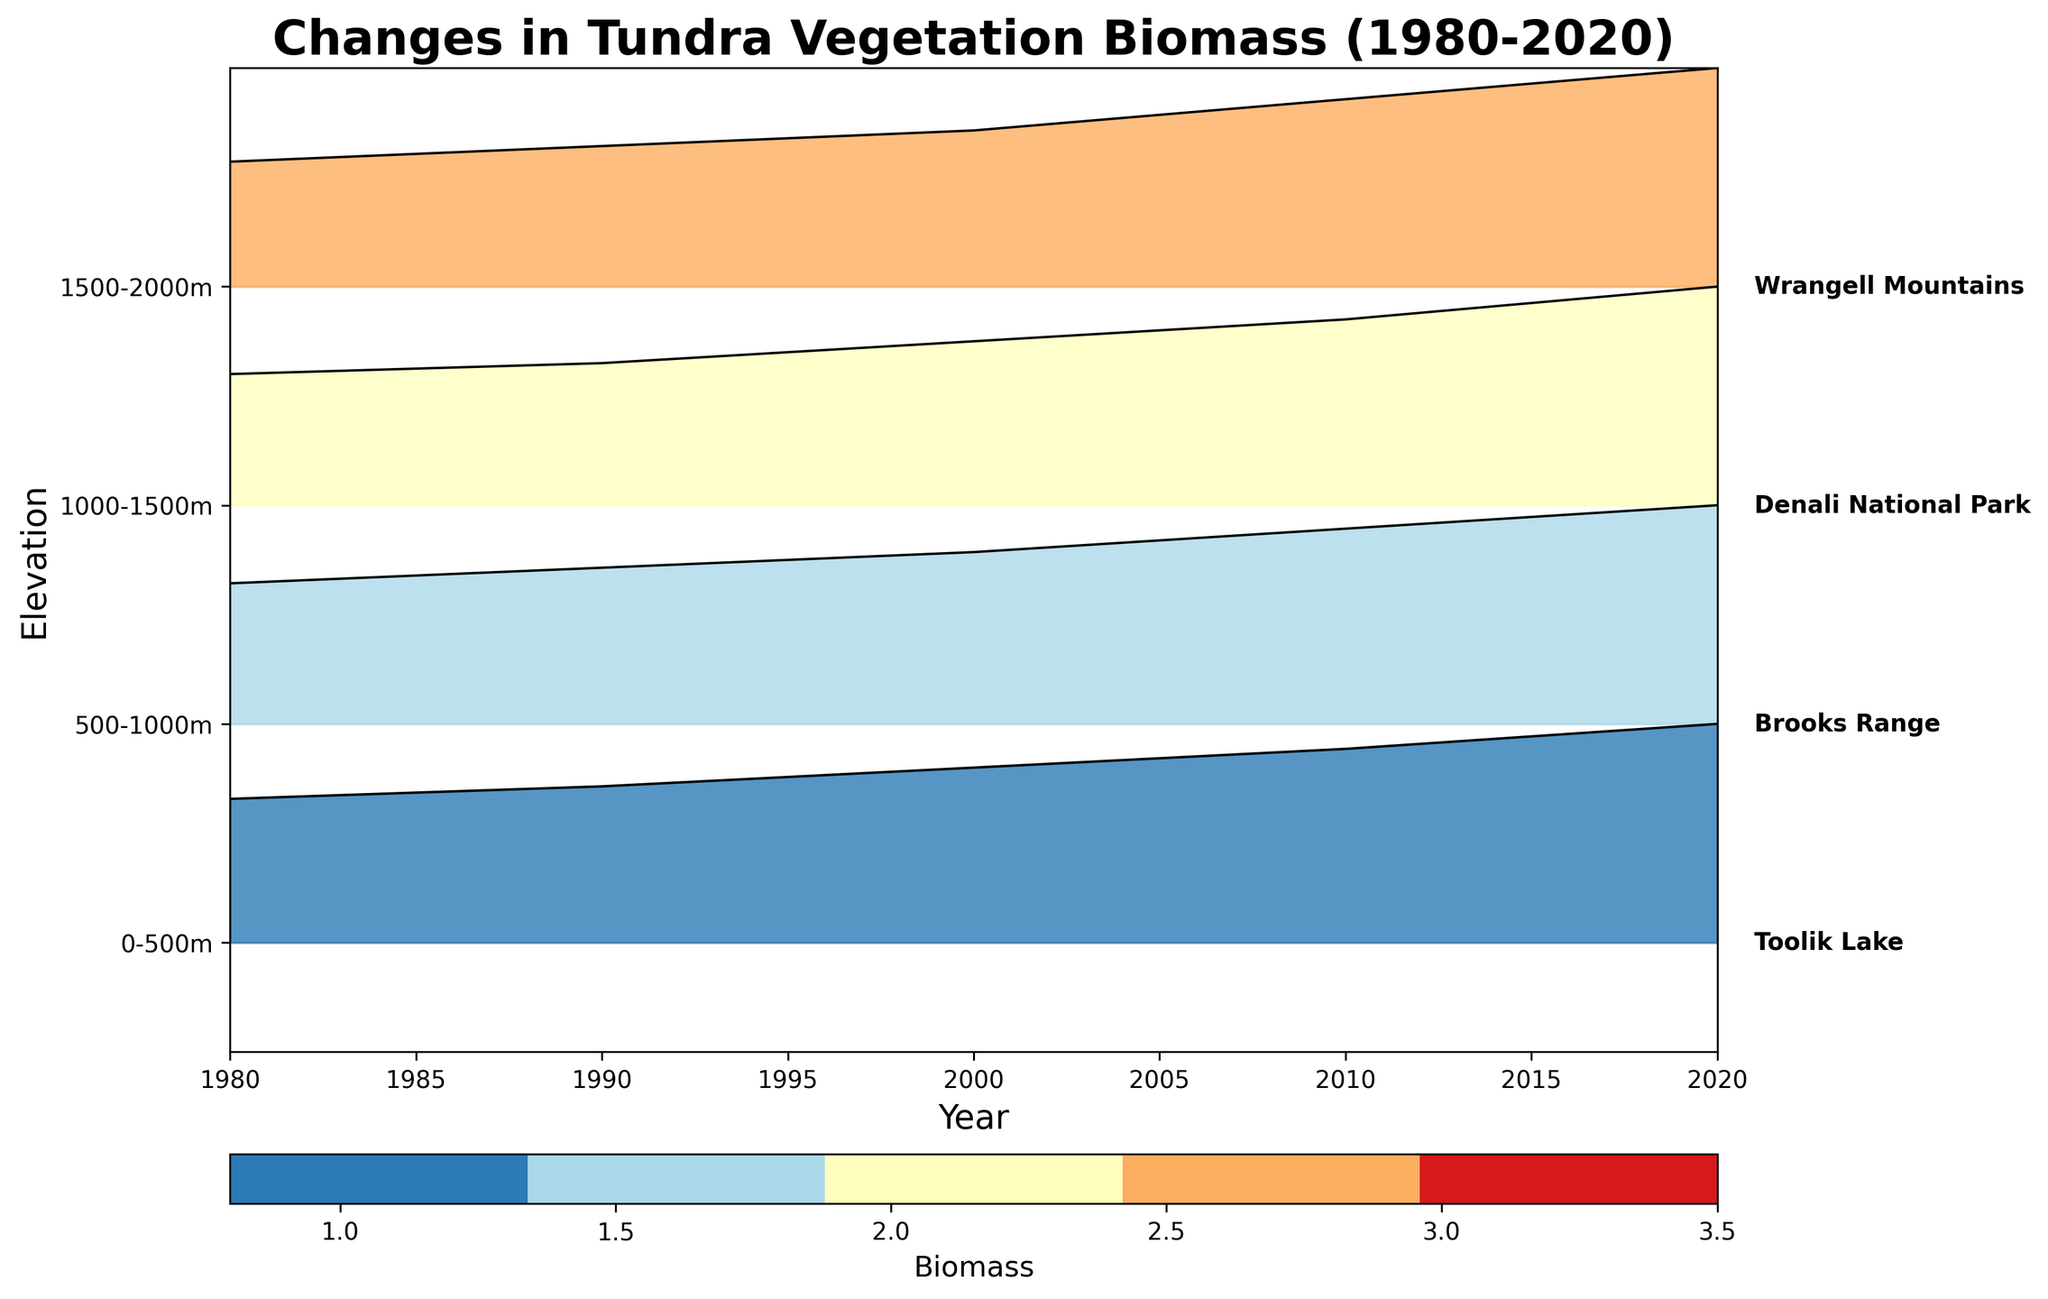What is the title of the plot? The title is typically displayed at the top of the figure. It provides a brief description of what the plot is about. In this case, you can see the title at the top center of the plot.
Answer: Changes in Tundra Vegetation Biomass (1980-2020) What are the labels on the x-axis and y-axis? The labels on the axes describe what each axis represents. The x-axis label is located below the horizontal axis, and the y-axis label is located to the left of the vertical axis.
Answer: Year (x-axis) and Elevation (y-axis) How many elevation gradients are represented in the plot? The number of unique elevation gradients can be counted on the y-axis. Each distinct label represents a different elevation gradient.
Answer: Four What trend can you observe in the biomass values over the years? By looking at how the lines and shaded areas filled with color move from left (1980) to right (2020) for each elevation gradient, you can observe whether the biomass values increase, decrease, or remain stable over time.
Answer: Increasing trend Which elevation gradient has the highest biomass in 2020? By comparing the heights of the lines and the extent of the colored areas at the year 2020, you can determine which elevation gradient has the highest biomass value in that year.
Answer: 0-500m How does the biomass change from 1980 to 2020 for the 1500-2000m elevation? To find this, compare the height of the line and shaded area at 1980 and 2020 for the 1500-2000m elevation gradient.
Answer: It increases from 0.8 to 1.4 Which location corresponds to the 1000-1500m elevation gradient? Based on the labels added to the right of the plot beside each elevation gradient, you can find the location name associated with the 1000-1500m elevation.
Answer: Denali National Park Compare the biomass change between 0-500m and 1000-1500m elevations from 1980 to 2020. Which elevation experiences a greater increase? Calculate the difference in biomass values from 1980 to 2020 for both elevation gradients and compare the results.
Answer: 0-500m What pattern is observed in biomass values across different elevations in 2020? By examining the heights of the lines and shaded regions for different elevation gradients in the year 2020, you can identify if there's a specific pattern, like higher biomass at lower elevations.
Answer: Higher biomass at lower elevations Which elevation gradient shows the smallest absolute increase in biomass from 1980 to 2020? Calculate the biomass difference between 1980 and 2020 for each elevation gradient and identify the one with the smallest increase.
Answer: 1500-2000m 